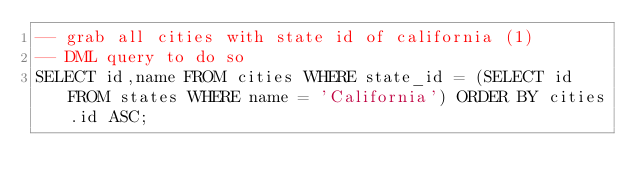<code> <loc_0><loc_0><loc_500><loc_500><_SQL_>-- grab all cities with state id of california (1)
-- DML query to do so
SELECT id,name FROM cities WHERE state_id = (SELECT id FROM states WHERE name = 'California') ORDER BY cities.id ASC;
</code> 